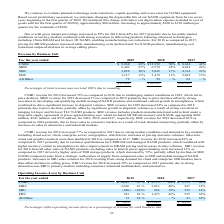According to Micron Technology's financial document, What was the primary cause of CNBU operating income for 2019 decreased from 2018? Based on the financial document, the answer is declines in pricing and higher R&D costs, partially offset by cost reductions. Also, Why did MBU operating income for 2018 improved from 2017? Based on the financial document, the answer is increases in pricing and sales volumes for LPDRAM products, higher sales of high-value managed NAND products, and manufacturing cost reductions. Also, Why did EBU operating income for 2018 increased as compared to 2017? Based on the financial document, the answer is increases in average selling prices, manufacturing cost reductions, and increases in sales volumes, partially offset by higher R&D costs. Also, can you calculate: What is the difference between EBU operating income in 2017 and 2018? Based on the calculation: 1,473 - 975 , the result is 498. This is based on the information: "EBU 923 29 % 1,473 42% 975 36% EBU 923 29 % 1,473 42% 975 36%..." The key data points involved are: 1,473, 975. Also, can you calculate: What is the ratio of CNBU and MBU total operating income in 2019 to those in 2018? To answer this question, I need to perform calculations using the financial data. The calculation is: (4,645+2,606)/(9,773+3,033), which equals 0.57. This is based on the information: "CNBU $ 4,645 47 % $ 9,773 64% $ 3,755 44% CNBU $ 4,645 47 % $ 9,773 64% $ 3,755 44% MBU 2,606 41 % 3,033 46% 927 21% MBU 2,606 41 % 3,033 46% 927 21%..." The key data points involved are: 2,606, 3,033, 4,645. Also, can you calculate: How much difference in the total operating income in 2018 compared to in 2017? Based on the calculation: 15,243 - 6,232 , the result is 9011. This is based on the information: "$ 7,801 $15,243 $ 6,232 $ 7,801 $15,243 $ 6,232..." The key data points involved are: 15,243, 6,232. 